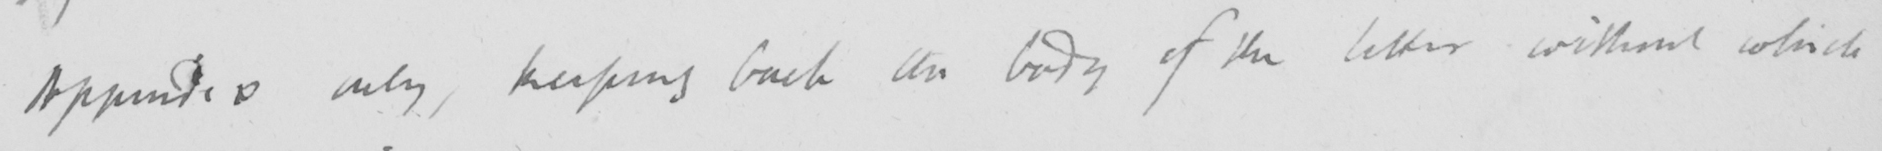What does this handwritten line say? Appendix only , keeping back the body of the letter without which 